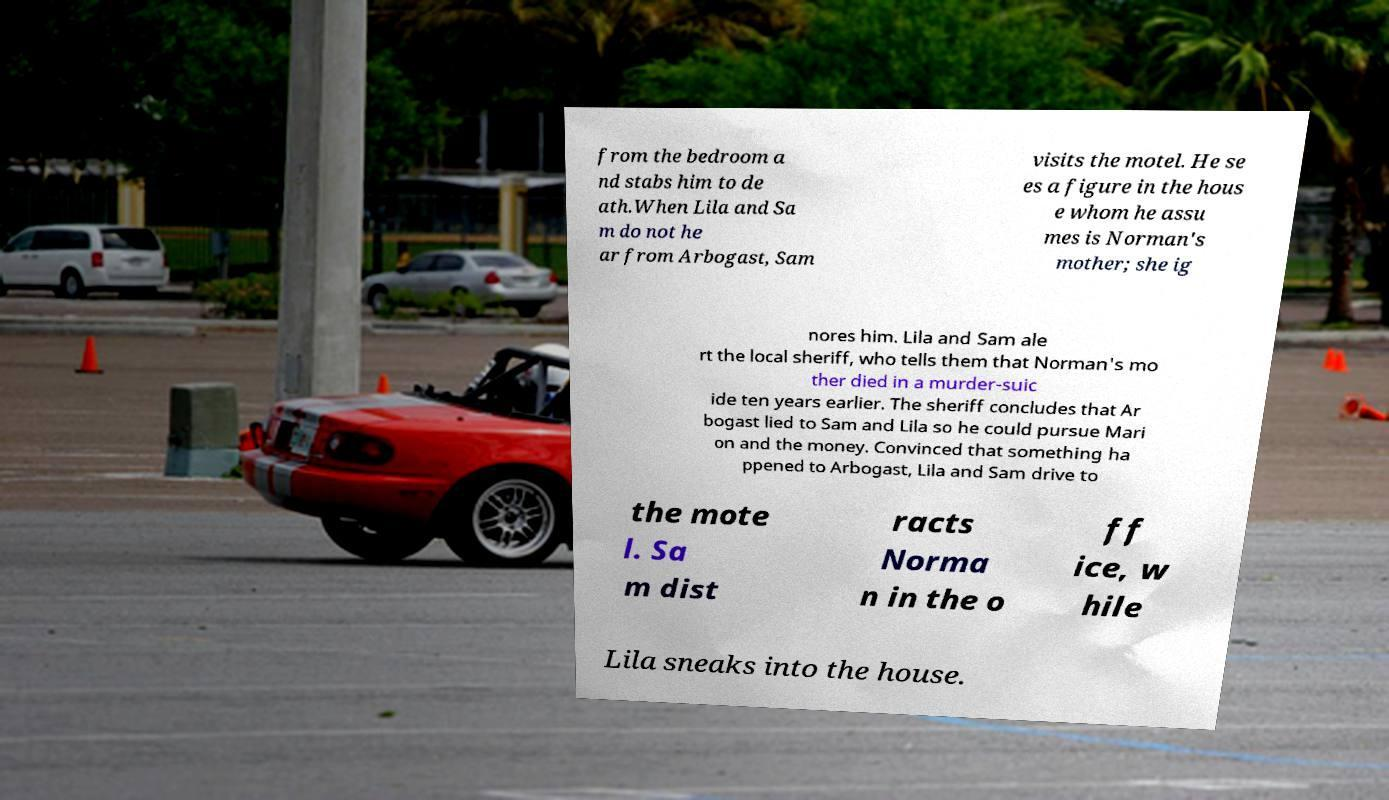Can you accurately transcribe the text from the provided image for me? from the bedroom a nd stabs him to de ath.When Lila and Sa m do not he ar from Arbogast, Sam visits the motel. He se es a figure in the hous e whom he assu mes is Norman's mother; she ig nores him. Lila and Sam ale rt the local sheriff, who tells them that Norman's mo ther died in a murder-suic ide ten years earlier. The sheriff concludes that Ar bogast lied to Sam and Lila so he could pursue Mari on and the money. Convinced that something ha ppened to Arbogast, Lila and Sam drive to the mote l. Sa m dist racts Norma n in the o ff ice, w hile Lila sneaks into the house. 